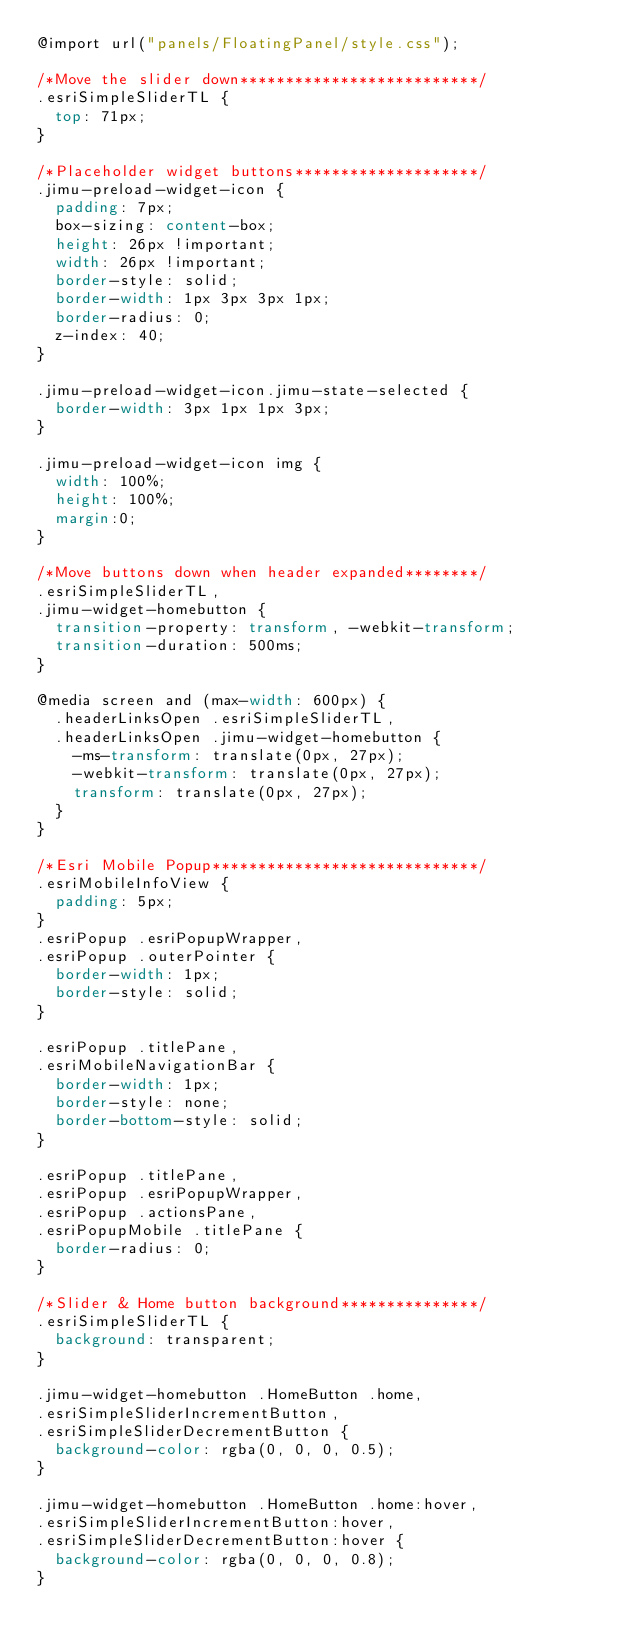Convert code to text. <code><loc_0><loc_0><loc_500><loc_500><_CSS_>@import url("panels/FloatingPanel/style.css");

/*Move the slider down**************************/
.esriSimpleSliderTL {
	top: 71px;
}

/*Placeholder widget buttons********************/
.jimu-preload-widget-icon {
	padding: 7px;
	box-sizing: content-box;
	height: 26px !important;
	width: 26px !important;
	border-style: solid;
	border-width: 1px 3px 3px 1px;
	border-radius: 0;
	z-index: 40;
}

.jimu-preload-widget-icon.jimu-state-selected {
	border-width: 3px 1px 1px 3px;
}

.jimu-preload-widget-icon img {
	width: 100%;
	height: 100%;
	margin:0;
}

/*Move buttons down when header expanded********/
.esriSimpleSliderTL,
.jimu-widget-homebutton {
	transition-property: transform, -webkit-transform;
	transition-duration: 500ms;
}

@media screen and (max-width: 600px) {
	.headerLinksOpen .esriSimpleSliderTL,
	.headerLinksOpen .jimu-widget-homebutton {
		-ms-transform: translate(0px, 27px);
		-webkit-transform: translate(0px, 27px);
		transform: translate(0px, 27px);
	}
}

/*Esri Mobile Popup*****************************/
.esriMobileInfoView {
	padding: 5px;
}
.esriPopup .esriPopupWrapper,
.esriPopup .outerPointer {
	border-width: 1px;
	border-style: solid;
}

.esriPopup .titlePane,
.esriMobileNavigationBar {
	border-width: 1px;
	border-style: none;
	border-bottom-style: solid;
}

.esriPopup .titlePane,
.esriPopup .esriPopupWrapper,
.esriPopup .actionsPane,
.esriPopupMobile .titlePane {
	border-radius: 0;
}

/*Slider & Home button background***************/
.esriSimpleSliderTL {
	background: transparent;
}

.jimu-widget-homebutton .HomeButton .home,
.esriSimpleSliderIncrementButton,
.esriSimpleSliderDecrementButton {
	background-color: rgba(0, 0, 0, 0.5);
}

.jimu-widget-homebutton .HomeButton .home:hover,
.esriSimpleSliderIncrementButton:hover,
.esriSimpleSliderDecrementButton:hover {
	background-color: rgba(0, 0, 0, 0.8);
}</code> 